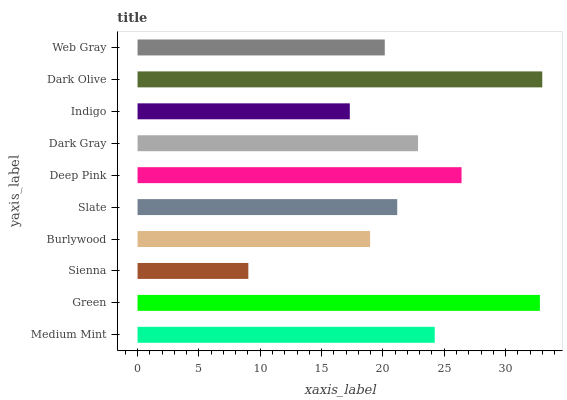Is Sienna the minimum?
Answer yes or no. Yes. Is Dark Olive the maximum?
Answer yes or no. Yes. Is Green the minimum?
Answer yes or no. No. Is Green the maximum?
Answer yes or no. No. Is Green greater than Medium Mint?
Answer yes or no. Yes. Is Medium Mint less than Green?
Answer yes or no. Yes. Is Medium Mint greater than Green?
Answer yes or no. No. Is Green less than Medium Mint?
Answer yes or no. No. Is Dark Gray the high median?
Answer yes or no. Yes. Is Slate the low median?
Answer yes or no. Yes. Is Indigo the high median?
Answer yes or no. No. Is Medium Mint the low median?
Answer yes or no. No. 